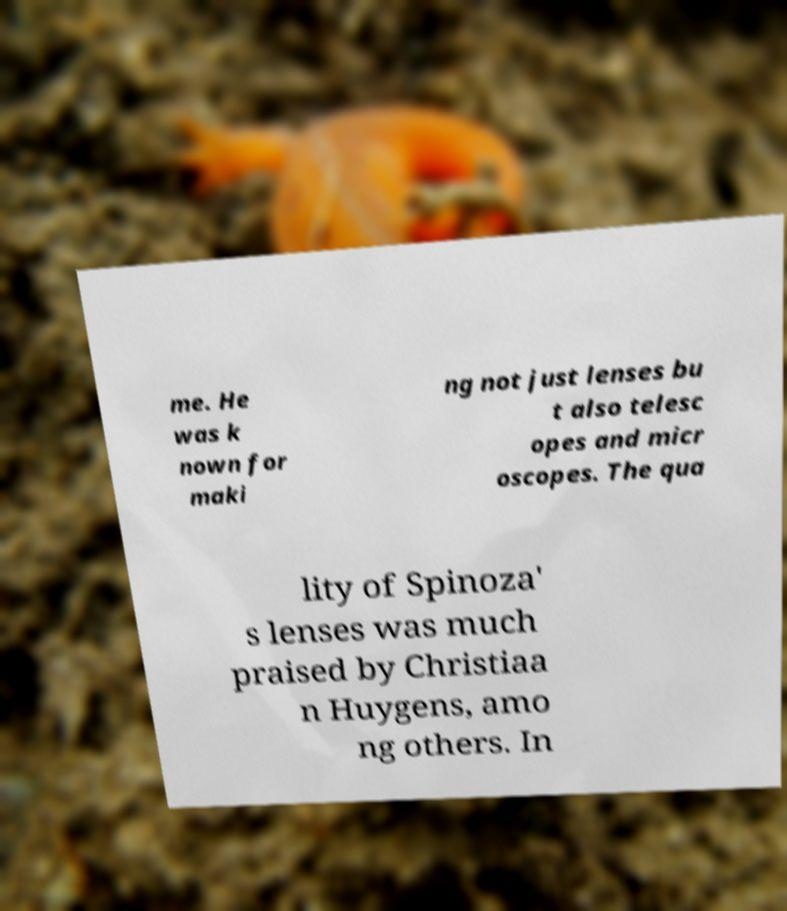Could you assist in decoding the text presented in this image and type it out clearly? me. He was k nown for maki ng not just lenses bu t also telesc opes and micr oscopes. The qua lity of Spinoza' s lenses was much praised by Christiaa n Huygens, amo ng others. In 